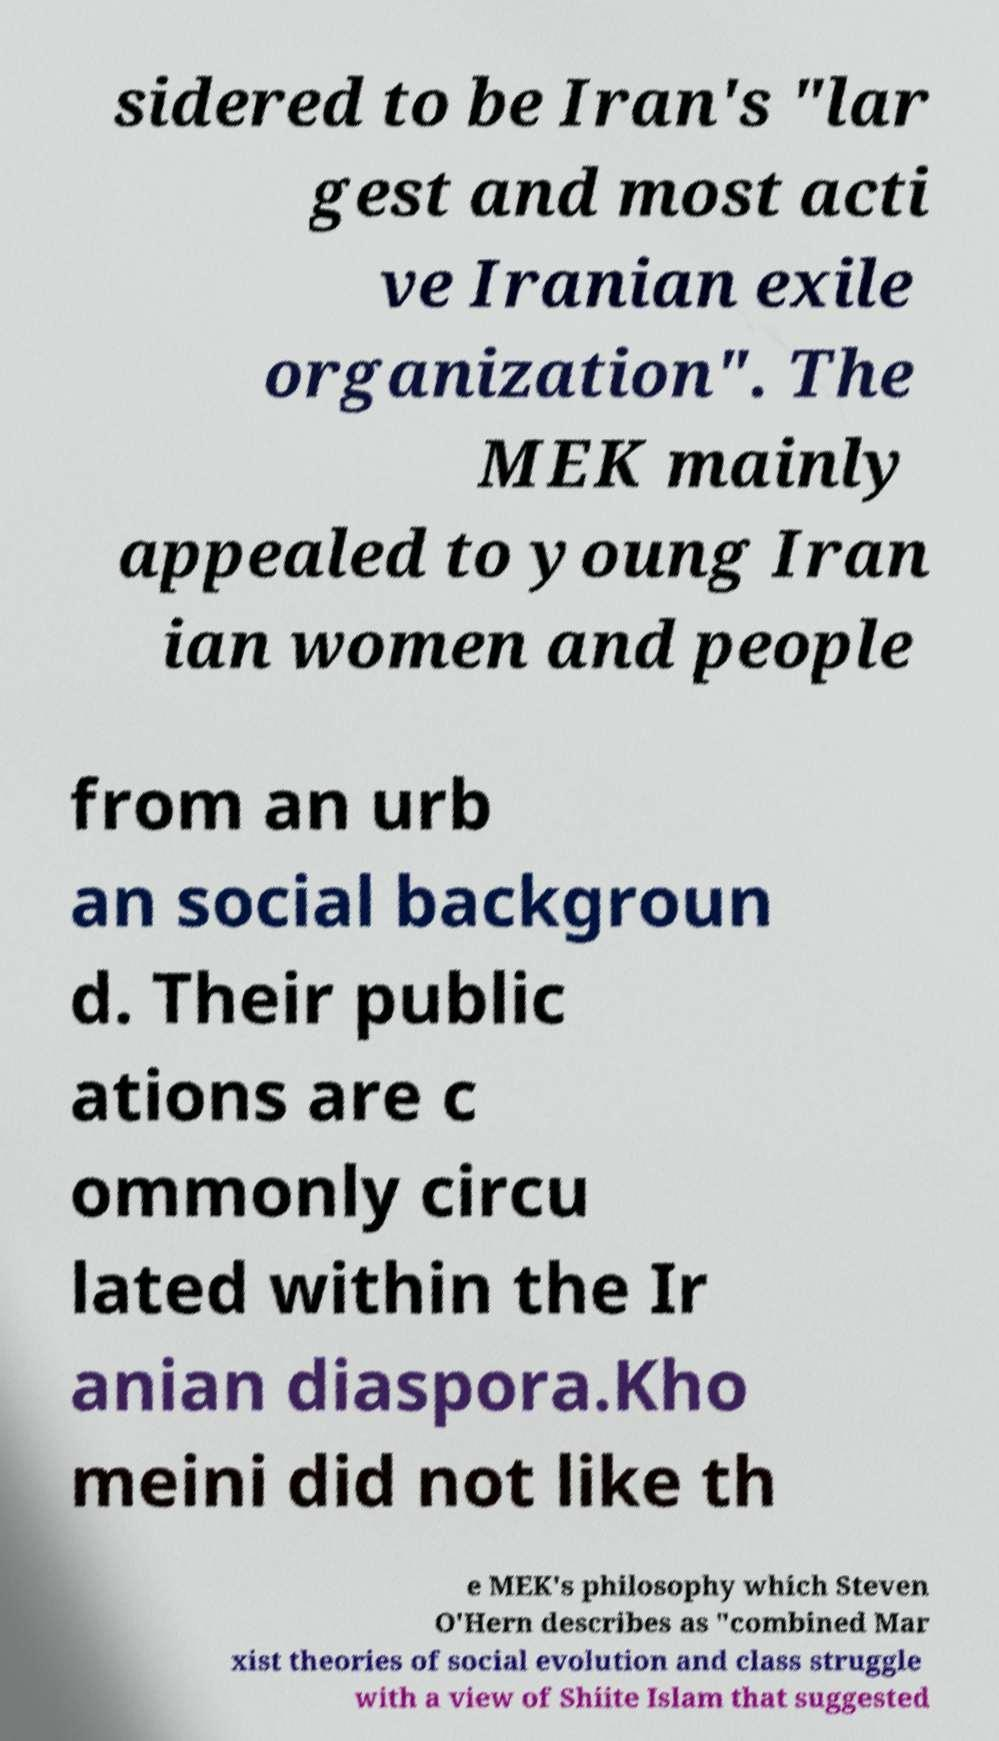Could you assist in decoding the text presented in this image and type it out clearly? sidered to be Iran's "lar gest and most acti ve Iranian exile organization". The MEK mainly appealed to young Iran ian women and people from an urb an social backgroun d. Their public ations are c ommonly circu lated within the Ir anian diaspora.Kho meini did not like th e MEK's philosophy which Steven O'Hern describes as "combined Mar xist theories of social evolution and class struggle with a view of Shiite Islam that suggested 